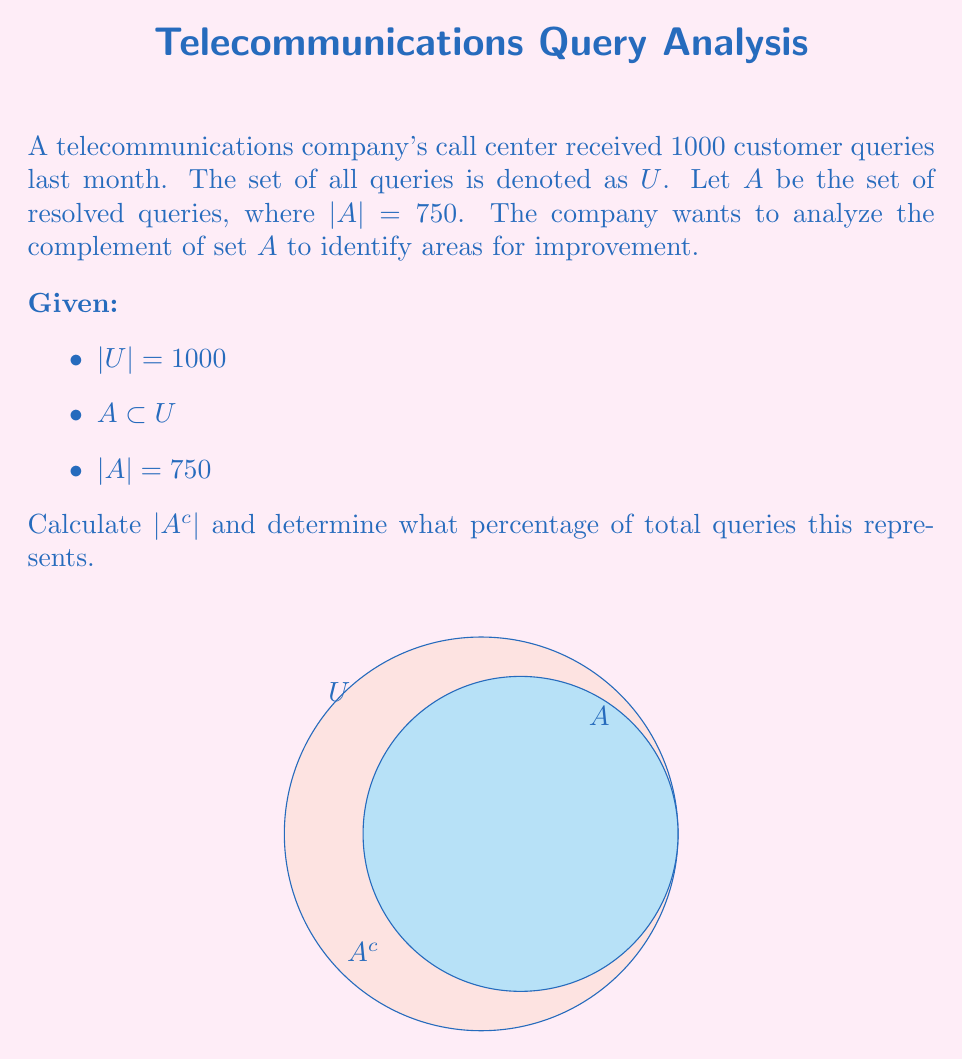Teach me how to tackle this problem. To solve this problem, we'll follow these steps:

1) First, recall that the complement of set $A$, denoted as $A^c$, is the set of all elements in the universal set $U$ that are not in $A$.

2) We know that $|U| = 1000$ and $|A| = 750$. To find $|A^c|$, we can use the relationship:

   $|U| = |A| + |A^c|$

3) Substituting the known values:

   $1000 = 750 + |A^c|$

4) Solving for $|A^c|$:

   $|A^c| = 1000 - 750 = 250$

5) To calculate the percentage of total queries this represents:

   Percentage = $\frac{|A^c|}{|U|} \times 100\%$
               = $\frac{250}{1000} \times 100\%$
               = $0.25 \times 100\%$
               = $25\%$

Therefore, the complement set $A^c$ contains 250 queries, representing 25% of the total queries. These are the unresolved queries that the company should focus on to improve their call center operations.
Answer: $|A^c| = 250$, $25\%$ of total queries 